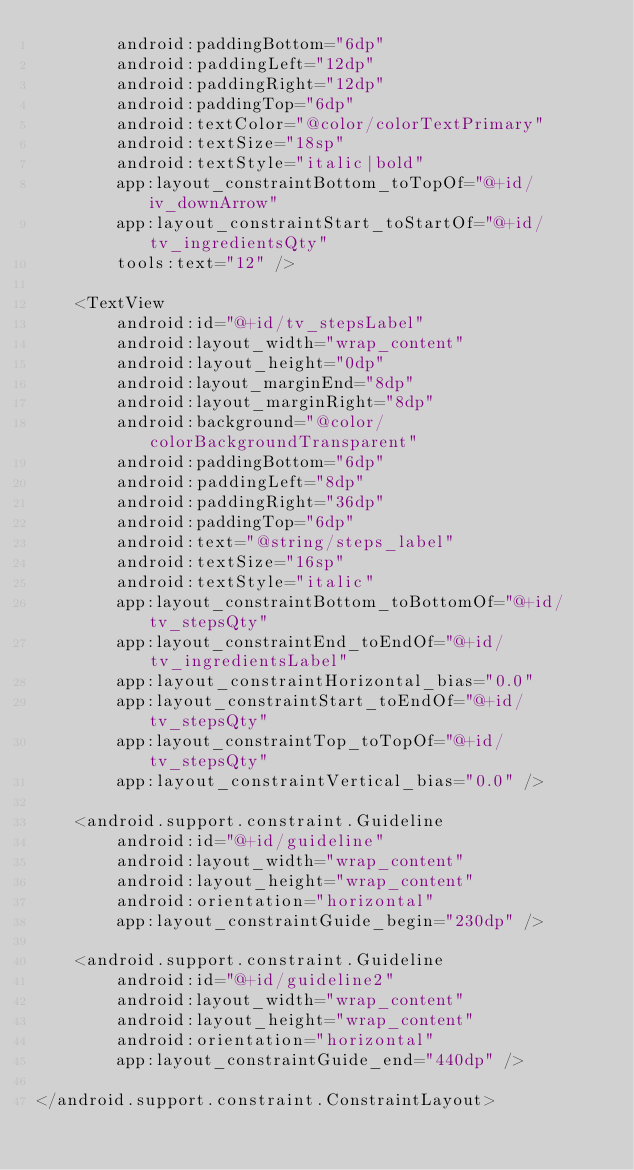Convert code to text. <code><loc_0><loc_0><loc_500><loc_500><_XML_>        android:paddingBottom="6dp"
        android:paddingLeft="12dp"
        android:paddingRight="12dp"
        android:paddingTop="6dp"
        android:textColor="@color/colorTextPrimary"
        android:textSize="18sp"
        android:textStyle="italic|bold"
        app:layout_constraintBottom_toTopOf="@+id/iv_downArrow"
        app:layout_constraintStart_toStartOf="@+id/tv_ingredientsQty"
        tools:text="12" />

    <TextView
        android:id="@+id/tv_stepsLabel"
        android:layout_width="wrap_content"
        android:layout_height="0dp"
        android:layout_marginEnd="8dp"
        android:layout_marginRight="8dp"
        android:background="@color/colorBackgroundTransparent"
        android:paddingBottom="6dp"
        android:paddingLeft="8dp"
        android:paddingRight="36dp"
        android:paddingTop="6dp"
        android:text="@string/steps_label"
        android:textSize="16sp"
        android:textStyle="italic"
        app:layout_constraintBottom_toBottomOf="@+id/tv_stepsQty"
        app:layout_constraintEnd_toEndOf="@+id/tv_ingredientsLabel"
        app:layout_constraintHorizontal_bias="0.0"
        app:layout_constraintStart_toEndOf="@+id/tv_stepsQty"
        app:layout_constraintTop_toTopOf="@+id/tv_stepsQty"
        app:layout_constraintVertical_bias="0.0" />

    <android.support.constraint.Guideline
        android:id="@+id/guideline"
        android:layout_width="wrap_content"
        android:layout_height="wrap_content"
        android:orientation="horizontal"
        app:layout_constraintGuide_begin="230dp" />

    <android.support.constraint.Guideline
        android:id="@+id/guideline2"
        android:layout_width="wrap_content"
        android:layout_height="wrap_content"
        android:orientation="horizontal"
        app:layout_constraintGuide_end="440dp" />

</android.support.constraint.ConstraintLayout></code> 